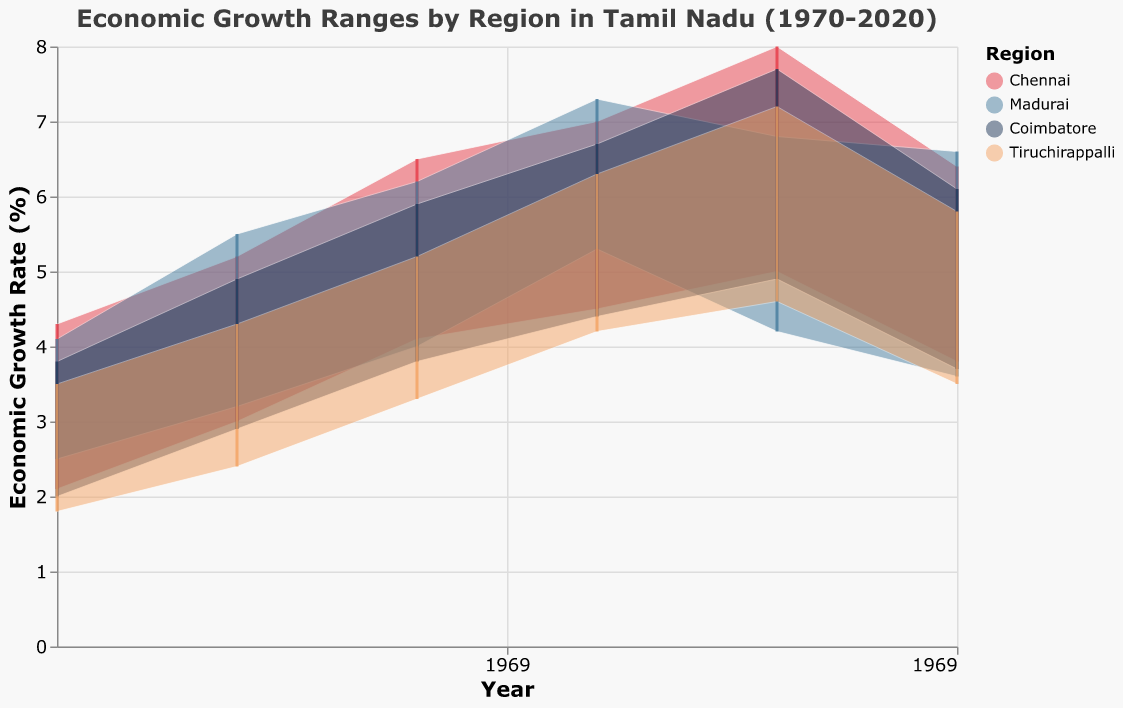What is the range of economic growth in Chennai in 1990? Look at the pair of values corresponding to Chennai in 1990. The range is given by the low and high points.
Answer: 4.1 to 6.5 Which region shows the highest upper limit of economic growth in 2000? Identify the upper limit values for each region in 2000, then find the maximum value.
Answer: Chennai (7.0%) In Madurai, which political party was in power during the highest economic growth range throughout the years shown, and what was the range? Compare the economic growth ranges for the years under different parties in Madurai. Identify the year with the highest range.
Answer: Dravida Munnetra Kazhagam in 2000 (5.3 to 7.3) Which region experienced an economic growth range of 3.7 to 6.1 in 2020? Look at the data points in 2020 and match the specified range.
Answer: Coimbatore Compare the economic growth ranges between Dravida Munnetra Kazhagam and All India Anna Dravida Munnetra Kazhagam in Chennai during 2010. Which party had the higher range? Find the economic growth ranges for both parties in Chennai for 2010, compare the ranges. Dravida Munnetra Kazhagam: 5.0 to 8.0, All India Anna Dravida Munnetra Kazhagam: not in power in 2010
Answer: Dravida Munnetra Kazhagam What was the economic growth trend in Tiruchirappalli between 1970 to 2020? Analyze the changes in economic growth range in Tiruchirappalli over the years 1970, 1980, 1990, 2000, 2010, and 2020.
Answer: Gradual increase until 2010, then a slight decline in 2020 How does the economic growth range in Chennai in 2020 compare to that in 2000? Determine the ranges for Chennai in both years and compare the differences.
Answer: 2020: 3.8 to 6.4, 2000: 4.5 to 7.0; 2020 is lower than 2000 What are the average highs of economic growth rates in Madurai during the 1980s and 2000s? Calculate the average economic growth high values for Madurai during the 1980s (1980) and 2000s (2000, 2010), and compare the two.
Answer: 1980s: 5.5, 2000s: 7.05 In which region do we see the largest decline in the upper range of economic growth from one decade to the next, and what are the values? Identify the largest decrease in the upper range of economic growth between any two consecutive decades for any region.
Answer: Coimbatore, 2010 to 2020 (7.7 to 6.1) What is the difference between the upper limits of economic growth in Madurai and Chennai in 2010? Find the upper limits of economic growth for both regions in 2010 and calculate the difference.
Answer: Chennai: 8.0, Madurai: 6.8; Difference is 1.2 